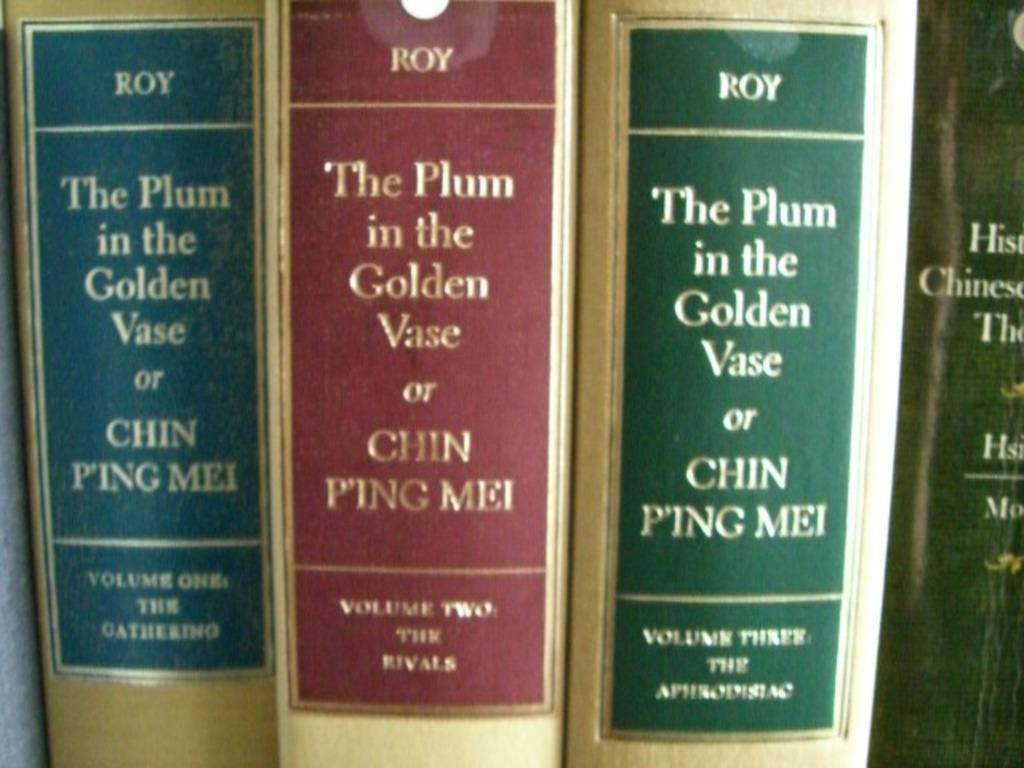<image>
Offer a succinct explanation of the picture presented. Three gold books by Roy called The Plum in the Golden Vase or Chin Ping Mei, each with a different color label: blue, red, and green. 